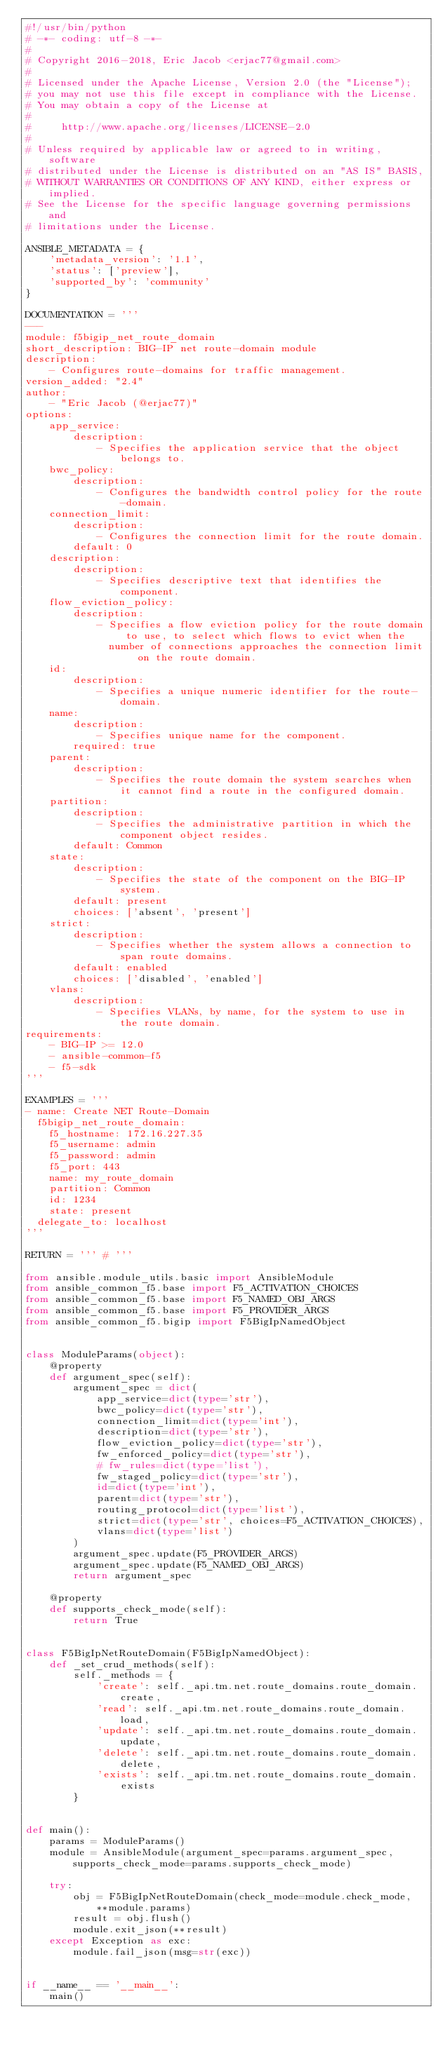<code> <loc_0><loc_0><loc_500><loc_500><_Python_>#!/usr/bin/python
# -*- coding: utf-8 -*-
#
# Copyright 2016-2018, Eric Jacob <erjac77@gmail.com>
#
# Licensed under the Apache License, Version 2.0 (the "License");
# you may not use this file except in compliance with the License.
# You may obtain a copy of the License at
#
#     http://www.apache.org/licenses/LICENSE-2.0
#
# Unless required by applicable law or agreed to in writing, software
# distributed under the License is distributed on an "AS IS" BASIS,
# WITHOUT WARRANTIES OR CONDITIONS OF ANY KIND, either express or implied.
# See the License for the specific language governing permissions and
# limitations under the License.

ANSIBLE_METADATA = {
    'metadata_version': '1.1',
    'status': ['preview'],
    'supported_by': 'community'
}

DOCUMENTATION = '''
---
module: f5bigip_net_route_domain
short_description: BIG-IP net route-domain module
description:
    - Configures route-domains for traffic management.
version_added: "2.4"
author:
    - "Eric Jacob (@erjac77)"
options:
    app_service:
        description:
            - Specifies the application service that the object belongs to.
    bwc_policy:
        description:
            - Configures the bandwidth control policy for the route-domain.
    connection_limit:
        description:
            - Configures the connection limit for the route domain.
        default: 0
    description:
        description:
            - Specifies descriptive text that identifies the component.
    flow_eviction_policy:
        description:
            - Specifies a flow eviction policy for the route domain to use, to select which flows to evict when the
              number of connections approaches the connection limit on the route domain.
    id:
        description:
            - Specifies a unique numeric identifier for the route-domain.
    name:
        description:
            - Specifies unique name for the component.
        required: true
    parent:
        description:
            - Specifies the route domain the system searches when it cannot find a route in the configured domain.
    partition:
        description:
            - Specifies the administrative partition in which the component object resides.
        default: Common
    state:
        description:
            - Specifies the state of the component on the BIG-IP system.
        default: present
        choices: ['absent', 'present']
    strict:
        description:
            - Specifies whether the system allows a connection to span route domains.
        default: enabled
        choices: ['disabled', 'enabled']
    vlans:
        description:
            - Specifies VLANs, by name, for the system to use in the route domain.
requirements:
    - BIG-IP >= 12.0
    - ansible-common-f5
    - f5-sdk
'''

EXAMPLES = '''
- name: Create NET Route-Domain
  f5bigip_net_route_domain:
    f5_hostname: 172.16.227.35
    f5_username: admin
    f5_password: admin
    f5_port: 443
    name: my_route_domain
    partition: Common
    id: 1234
    state: present
  delegate_to: localhost
'''

RETURN = ''' # '''

from ansible.module_utils.basic import AnsibleModule
from ansible_common_f5.base import F5_ACTIVATION_CHOICES
from ansible_common_f5.base import F5_NAMED_OBJ_ARGS
from ansible_common_f5.base import F5_PROVIDER_ARGS
from ansible_common_f5.bigip import F5BigIpNamedObject


class ModuleParams(object):
    @property
    def argument_spec(self):
        argument_spec = dict(
            app_service=dict(type='str'),
            bwc_policy=dict(type='str'),
            connection_limit=dict(type='int'),
            description=dict(type='str'),
            flow_eviction_policy=dict(type='str'),
            fw_enforced_policy=dict(type='str'),
            # fw_rules=dict(type='list'),
            fw_staged_policy=dict(type='str'),
            id=dict(type='int'),
            parent=dict(type='str'),
            routing_protocol=dict(type='list'),
            strict=dict(type='str', choices=F5_ACTIVATION_CHOICES),
            vlans=dict(type='list')
        )
        argument_spec.update(F5_PROVIDER_ARGS)
        argument_spec.update(F5_NAMED_OBJ_ARGS)
        return argument_spec

    @property
    def supports_check_mode(self):
        return True


class F5BigIpNetRouteDomain(F5BigIpNamedObject):
    def _set_crud_methods(self):
        self._methods = {
            'create': self._api.tm.net.route_domains.route_domain.create,
            'read': self._api.tm.net.route_domains.route_domain.load,
            'update': self._api.tm.net.route_domains.route_domain.update,
            'delete': self._api.tm.net.route_domains.route_domain.delete,
            'exists': self._api.tm.net.route_domains.route_domain.exists
        }


def main():
    params = ModuleParams()
    module = AnsibleModule(argument_spec=params.argument_spec, supports_check_mode=params.supports_check_mode)

    try:
        obj = F5BigIpNetRouteDomain(check_mode=module.check_mode, **module.params)
        result = obj.flush()
        module.exit_json(**result)
    except Exception as exc:
        module.fail_json(msg=str(exc))


if __name__ == '__main__':
    main()
</code> 